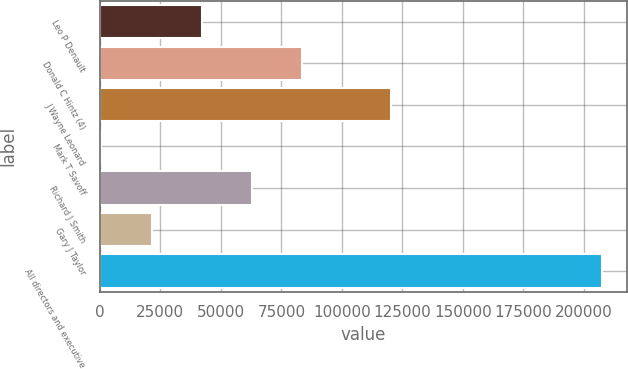Convert chart to OTSL. <chart><loc_0><loc_0><loc_500><loc_500><bar_chart><fcel>Leo P Denault<fcel>Donald C Hintz (4)<fcel>J Wayne Leonard<fcel>Mark T Savoff<fcel>Richard J Smith<fcel>Gary J Taylor<fcel>All directors and executive<nl><fcel>42034.6<fcel>83408.2<fcel>120453<fcel>661<fcel>62721.4<fcel>21347.8<fcel>207529<nl></chart> 